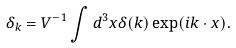Convert formula to latex. <formula><loc_0><loc_0><loc_500><loc_500>\delta _ { k } = V ^ { - 1 } \int d ^ { 3 } x \delta ( k ) \exp ( i { k } \cdot { x } ) .</formula> 